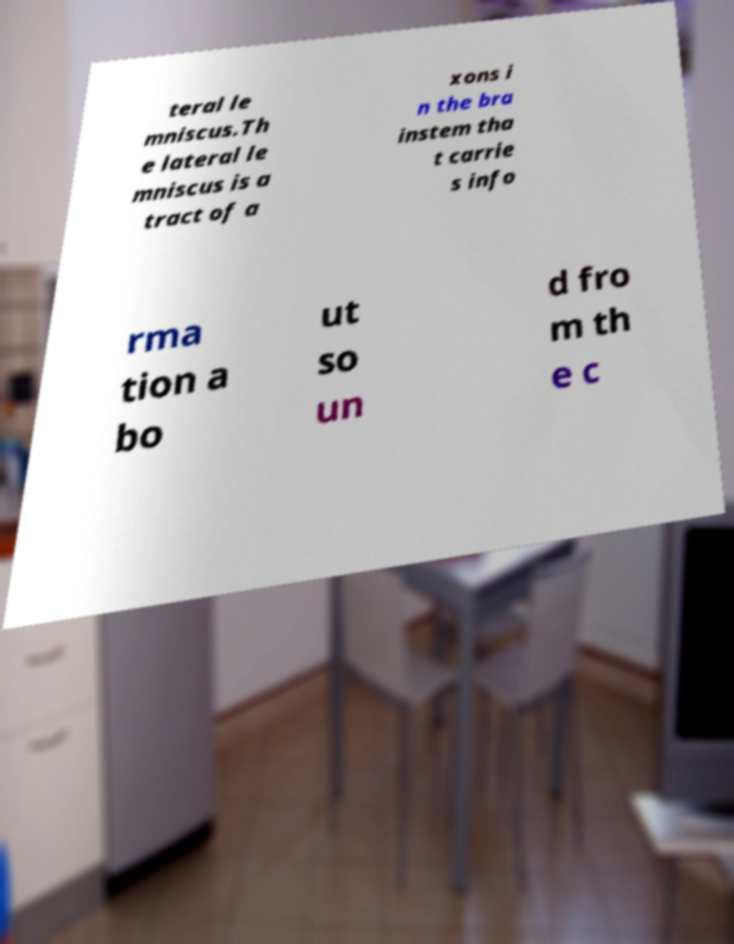Can you accurately transcribe the text from the provided image for me? teral le mniscus.Th e lateral le mniscus is a tract of a xons i n the bra instem tha t carrie s info rma tion a bo ut so un d fro m th e c 